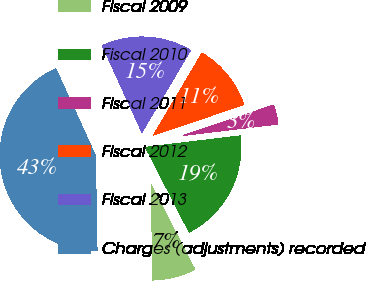Convert chart. <chart><loc_0><loc_0><loc_500><loc_500><pie_chart><fcel>Fiscal 2009<fcel>Fiscal 2010<fcel>Fiscal 2011<fcel>Fiscal 2012<fcel>Fiscal 2013<fcel>Charges (adjustments) recorded<nl><fcel>7.29%<fcel>19.35%<fcel>3.27%<fcel>11.31%<fcel>15.33%<fcel>43.45%<nl></chart> 